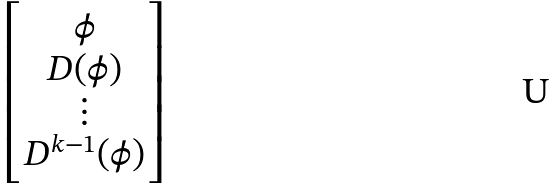Convert formula to latex. <formula><loc_0><loc_0><loc_500><loc_500>\begin{bmatrix} \phi \\ D ( \phi ) \\ \vdots \\ D ^ { k - 1 } ( \phi ) \end{bmatrix}</formula> 